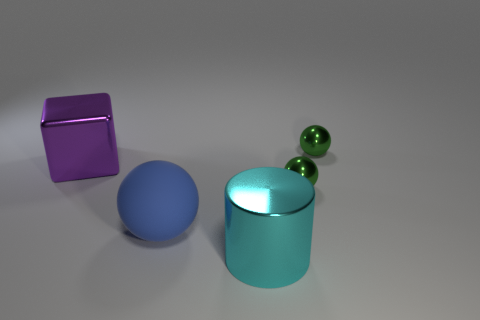Subtract all small balls. How many balls are left? 1 Subtract all blue balls. How many balls are left? 2 Subtract 2 spheres. How many spheres are left? 1 Add 1 big cyan objects. How many objects exist? 6 Subtract all cubes. How many objects are left? 4 Add 3 big cyan shiny cylinders. How many big cyan shiny cylinders exist? 4 Subtract 0 red spheres. How many objects are left? 5 Subtract all brown cubes. Subtract all gray cylinders. How many cubes are left? 1 Subtract all purple cubes. How many blue spheres are left? 1 Subtract all gray metal things. Subtract all blue matte objects. How many objects are left? 4 